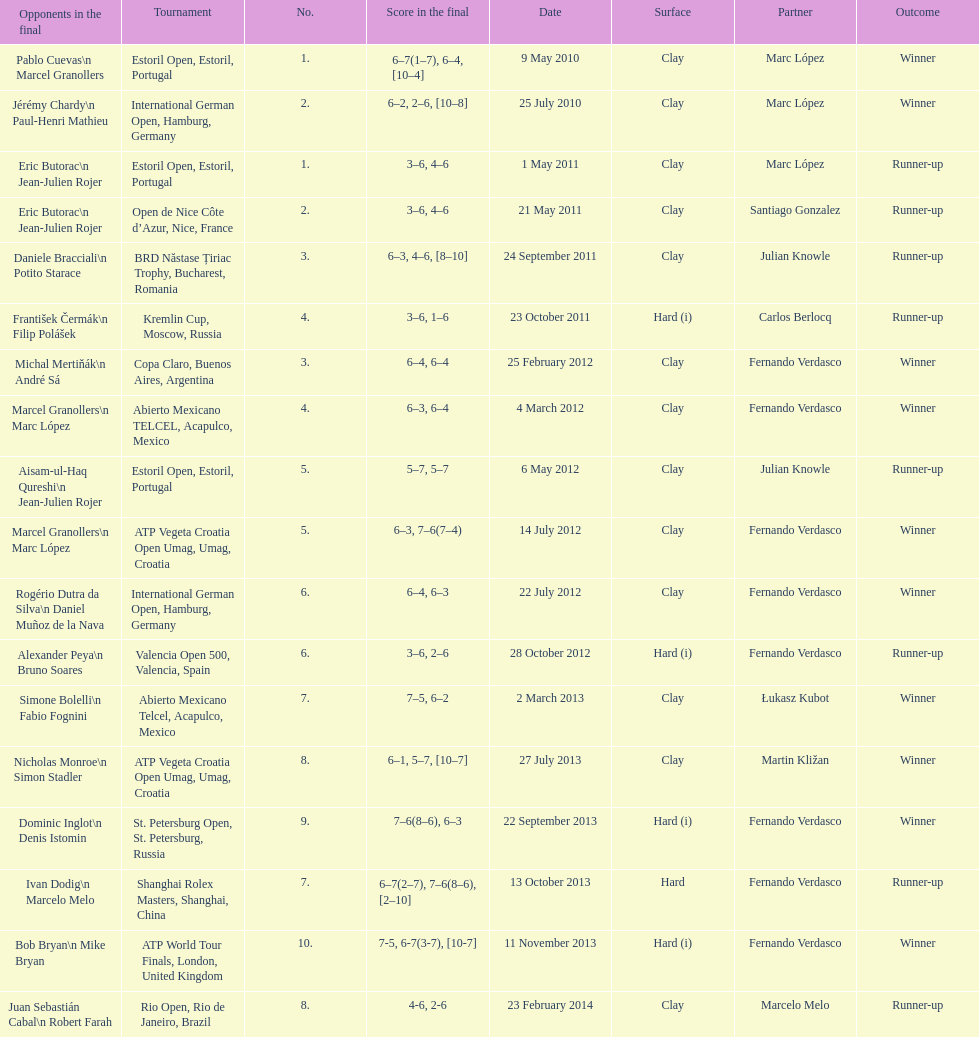What is the number of winning outcomes? 10. 